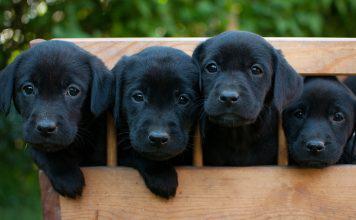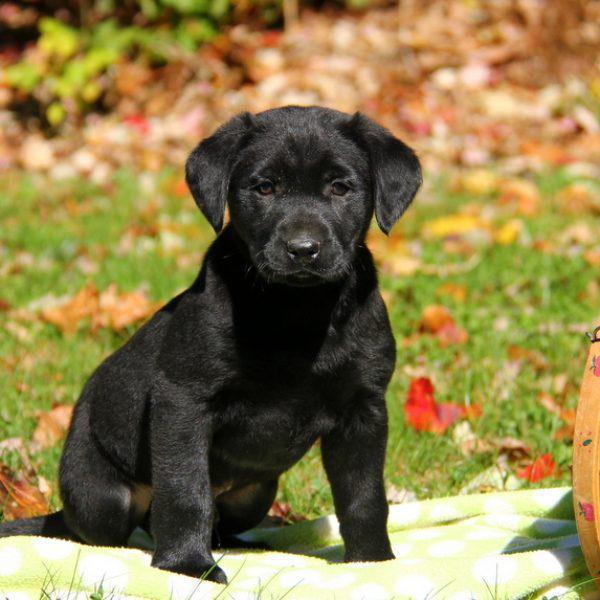The first image is the image on the left, the second image is the image on the right. Given the left and right images, does the statement "One image contains at least two all-black lab puppies posed side-by-side outdoors." hold true? Answer yes or no. Yes. 